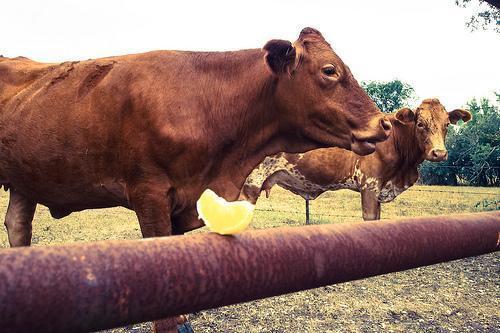How many orange slices are there?
Give a very brief answer. 1. How many cows do you see?
Give a very brief answer. 2. 